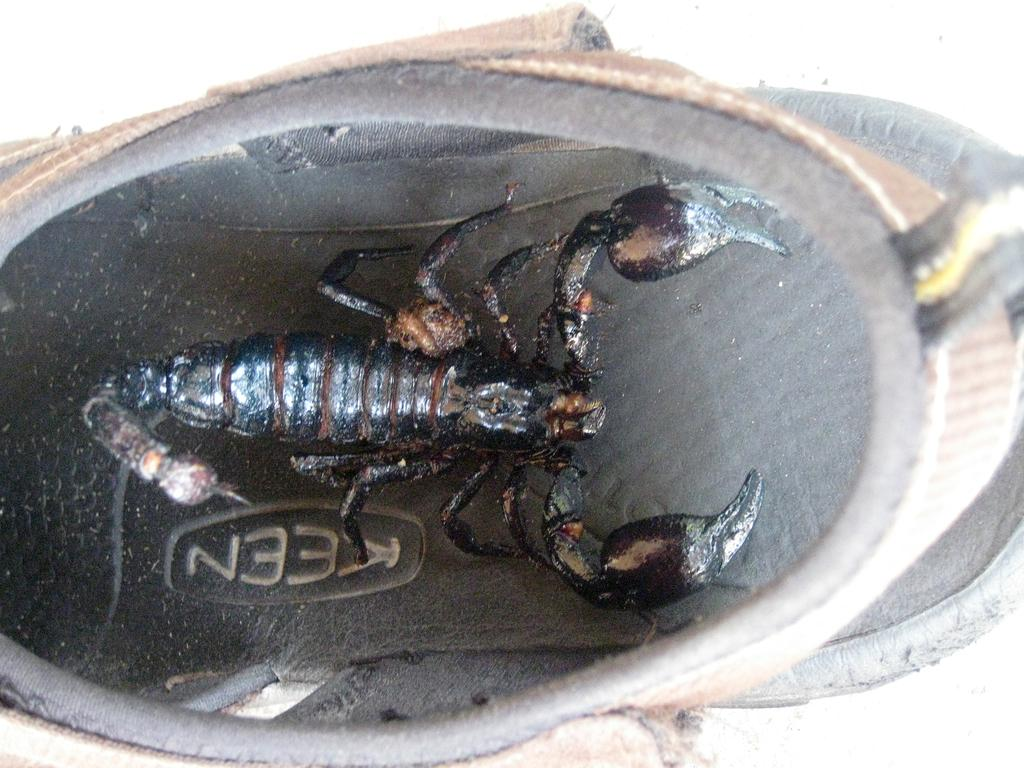<image>
Relay a brief, clear account of the picture shown. A scorpion is inside a Keen brand shoe. 